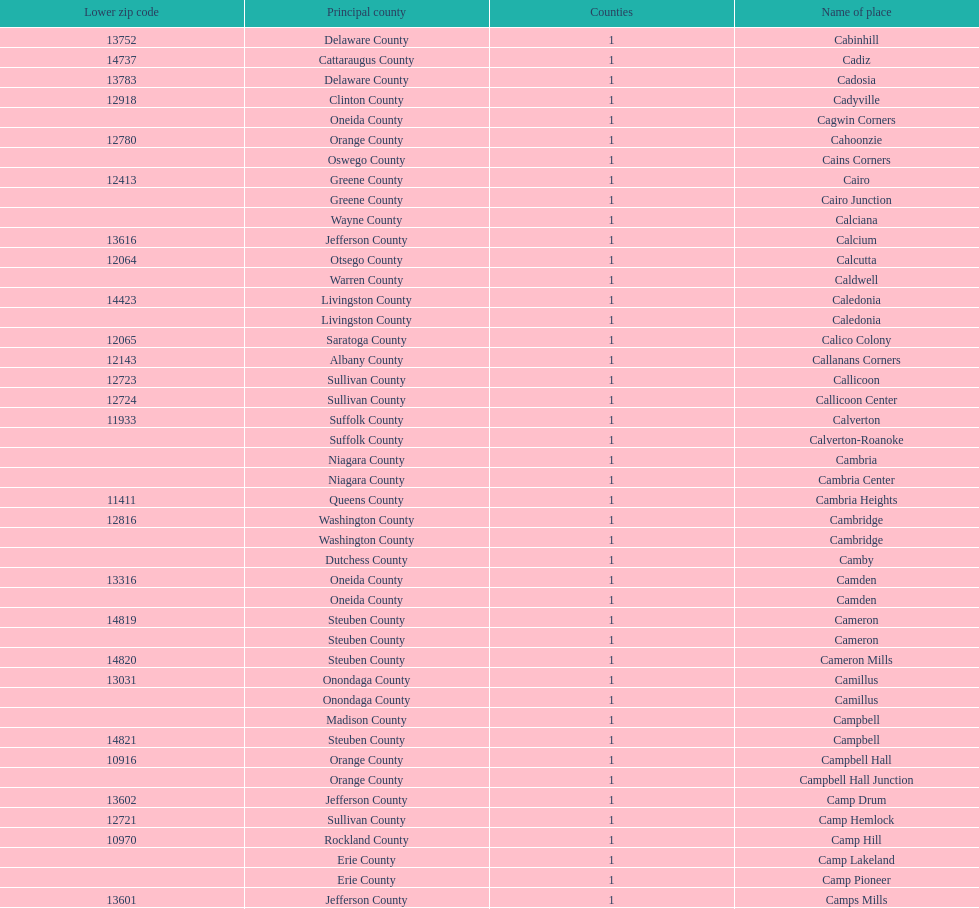How many places are in greene county? 10. 